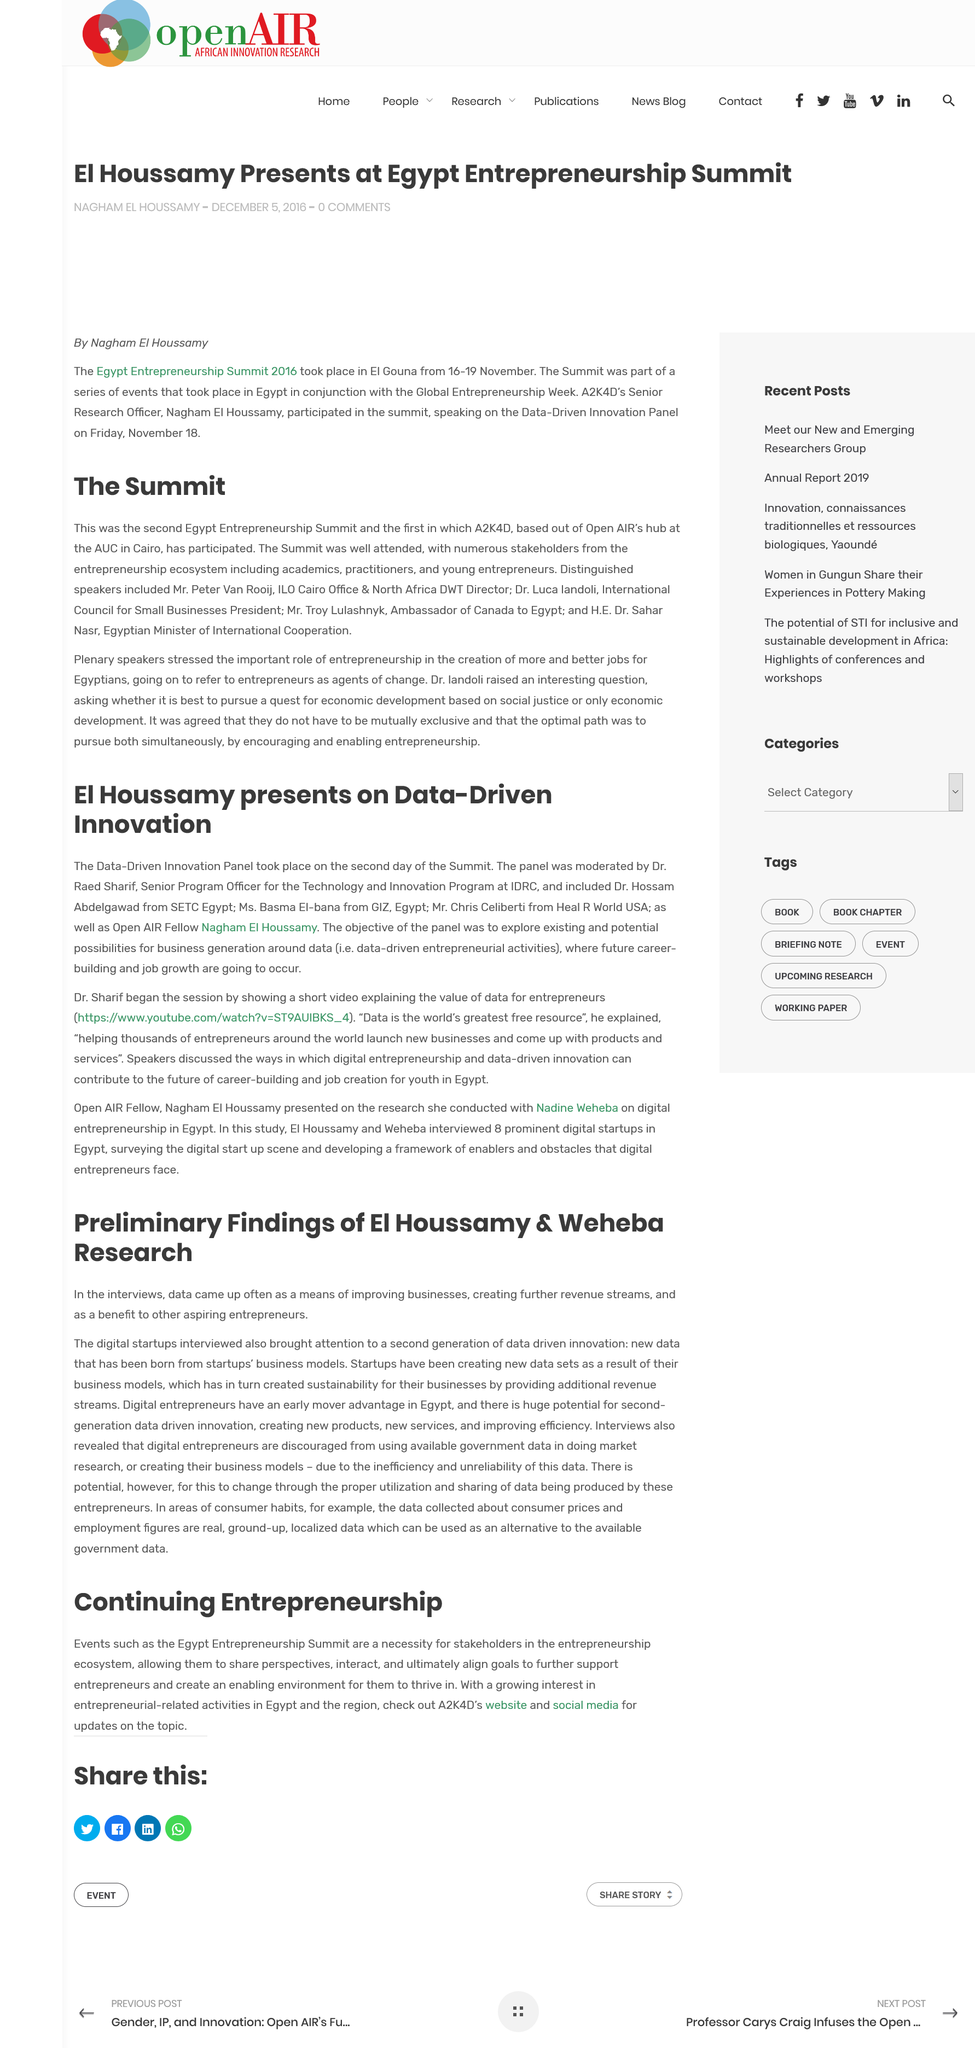List a handful of essential elements in this visual. Nagham El Houssamy is an Open AIR Fellow who is known for her contributions to the field. A2K4D participated in The Summit for the first time. The Panel took place on the second day of the Summit. Dr. Iandoli raised the question of whether it is best to pursue a quest for economic development based on social justice or only economic development, at the The Summit. Dr. Raed Sharif moderated the Panel. 